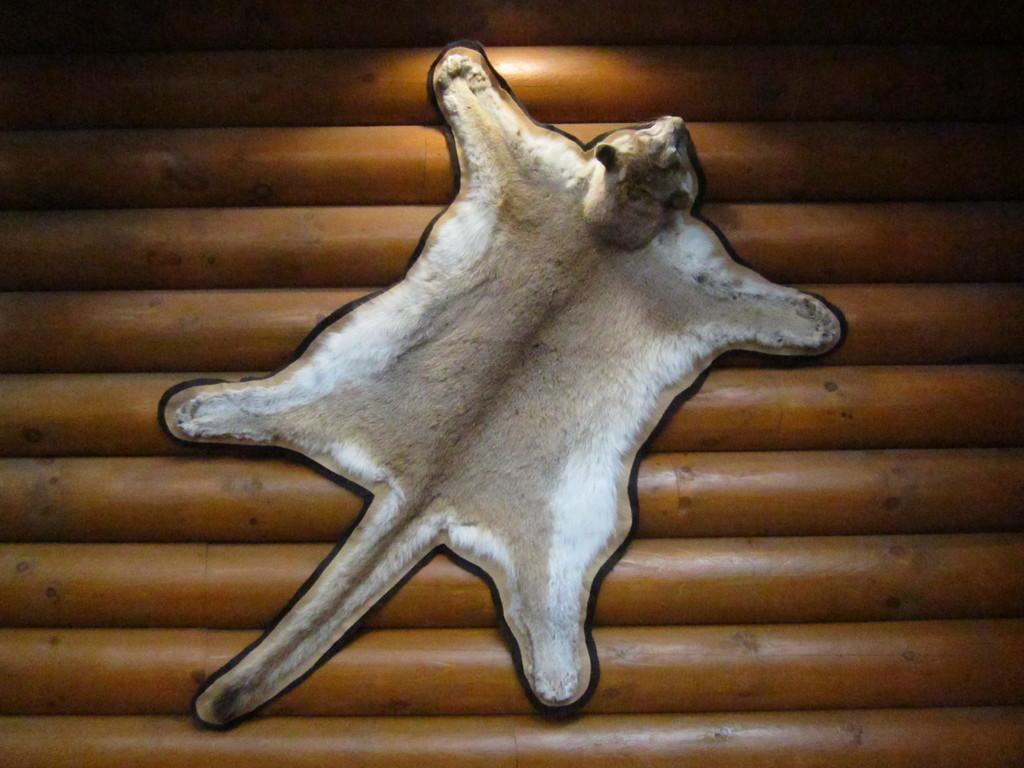What is the main subject of the image? The main subject of the image is a skin of an animal. What is the skin placed on in the image? The skin is on a wooden surface. What type of hair can be seen on the animal skin in the image? There is no hair visible on the animal skin in the image. What current is flowing through the wooden surface in the image? There is no current present in the image; it is a static wooden surface. 